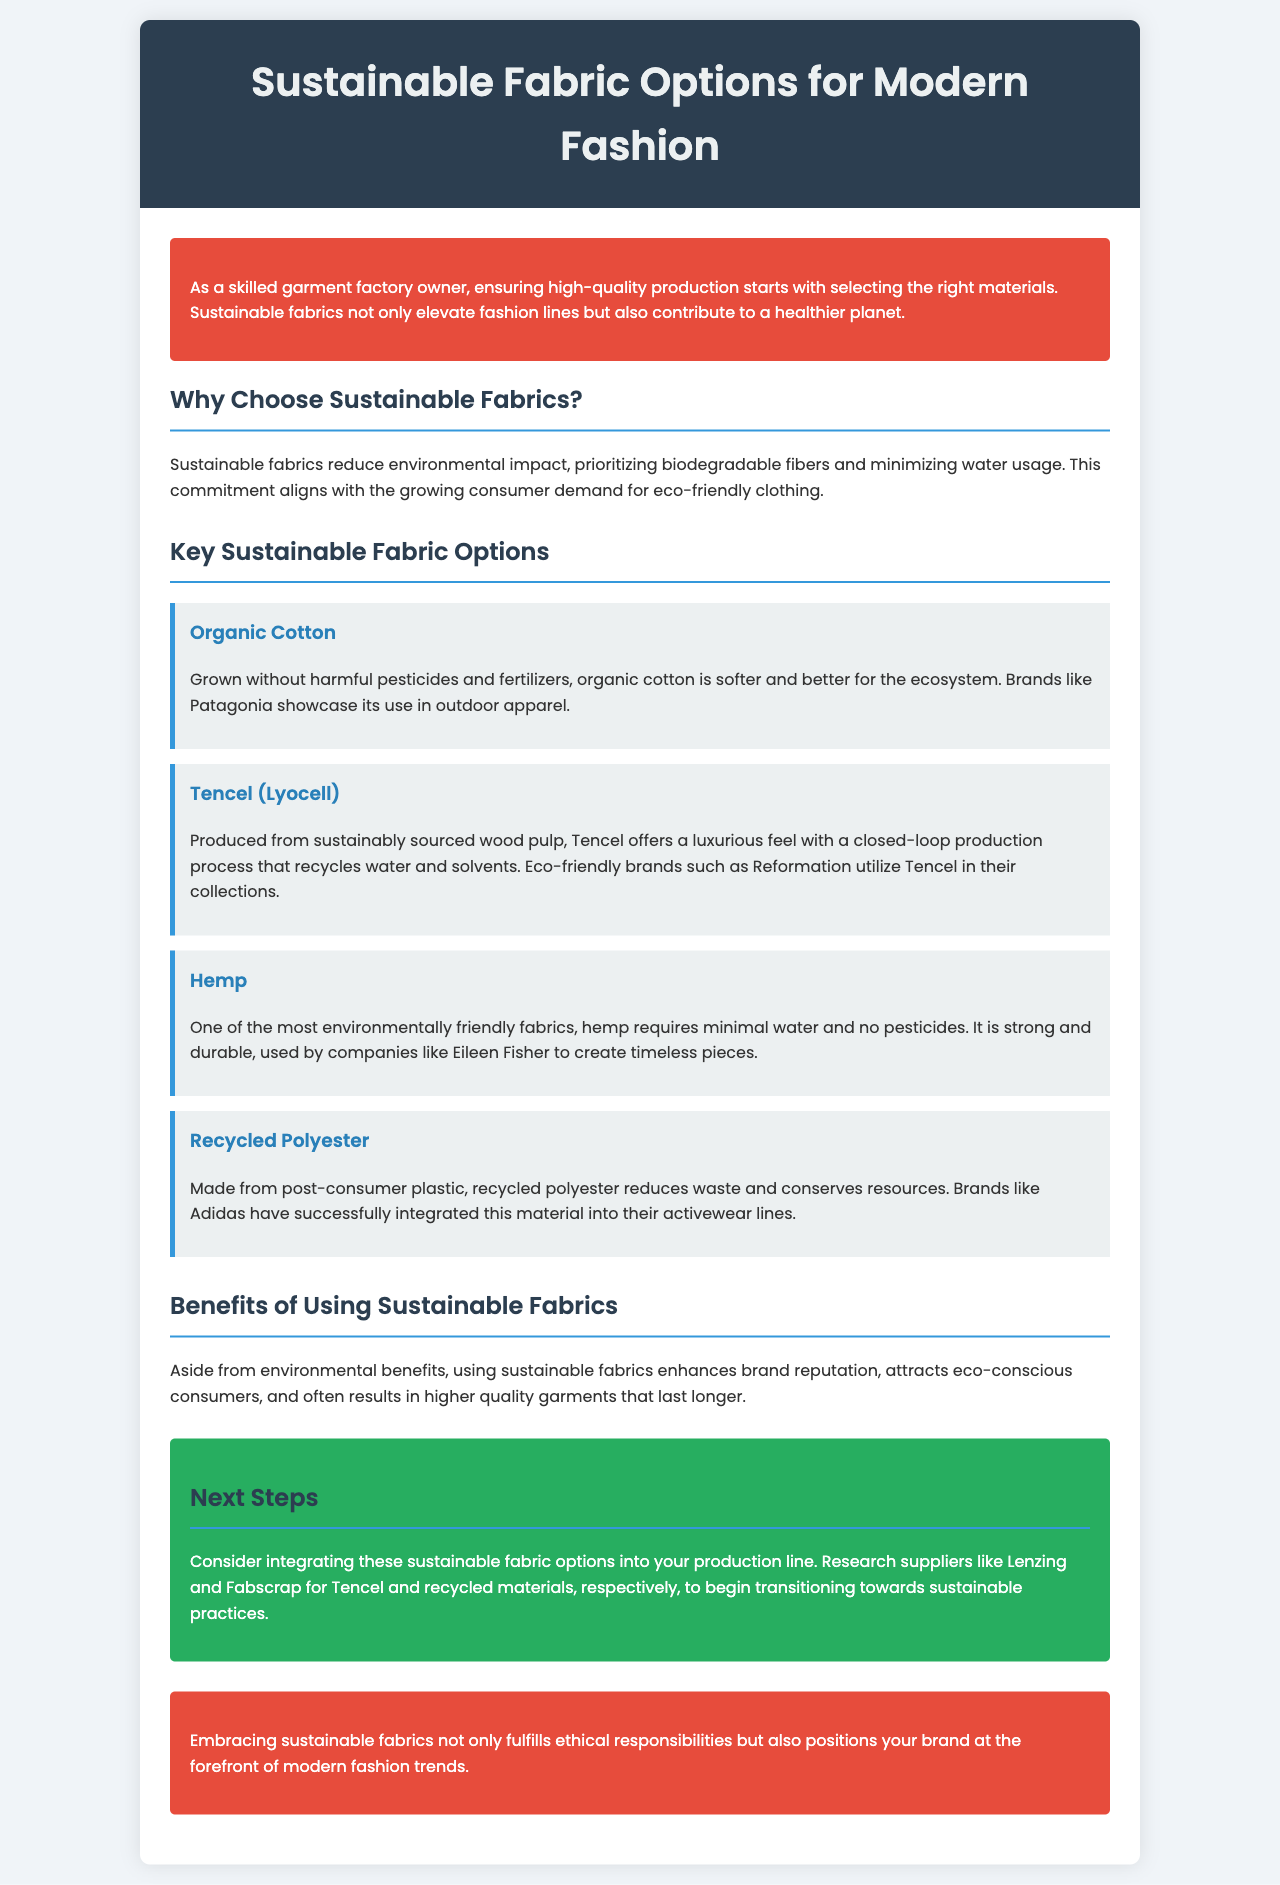what are the key sustainable fabric options listed? The document specifically highlights four sustainable fabric options: Organic Cotton, Tencel (Lyocell), Hemp, and Recycled Polyester.
Answer: Organic Cotton, Tencel (Lyocell), Hemp, Recycled Polyester who is one of the brands that use Organic Cotton? The document mentions Patagonia as a brand that showcases the use of organic cotton in outdoor apparel.
Answer: Patagonia what is the primary benefit of using sustainable fabrics mentioned? According to the brochure, aside from environmental benefits, sustainable fabrics enhance brand reputation and attract eco-conscious consumers.
Answer: Brand reputation how does Tencel (Lyocell) contribute to sustainability? The closed-loop production process of Tencel recycles water and solvents, making it an eco-friendly choice.
Answer: Recirculates water and solvents what minimal requirement does Hemp have for growth? The document states that hemp requires minimal water and no pesticides, making it one of the most environmentally-friendly fabrics.
Answer: Minimal water what is the color of the introduction section background? The introduction section background color is noted to be red.
Answer: Red what step should be taken next according to the brochure? The brochure advises integrating sustainable fabric options into your production line and researching suppliers for Tencel and recycled materials.
Answer: Integrate sustainable fabric options 